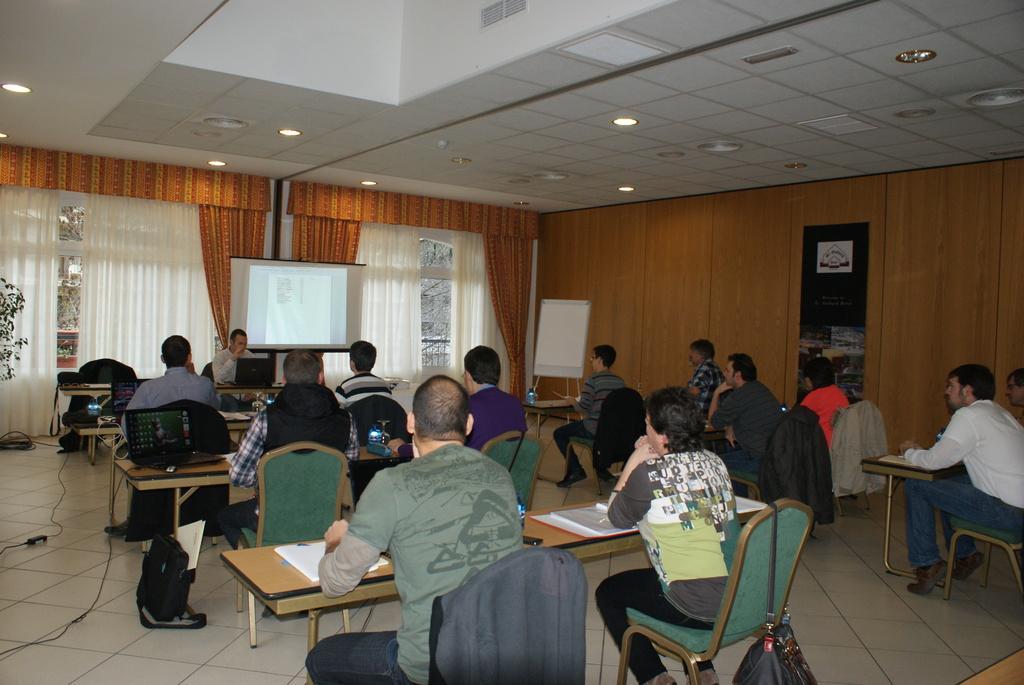Can you describe this image briefly? In this picture there are group of people sitting on the chair. There is a jacket on the chair. There is a bottle, phone, book, laptop, wire on the table. There is a whiteboard, screen and some lights. There is a plant and a white curtain. 